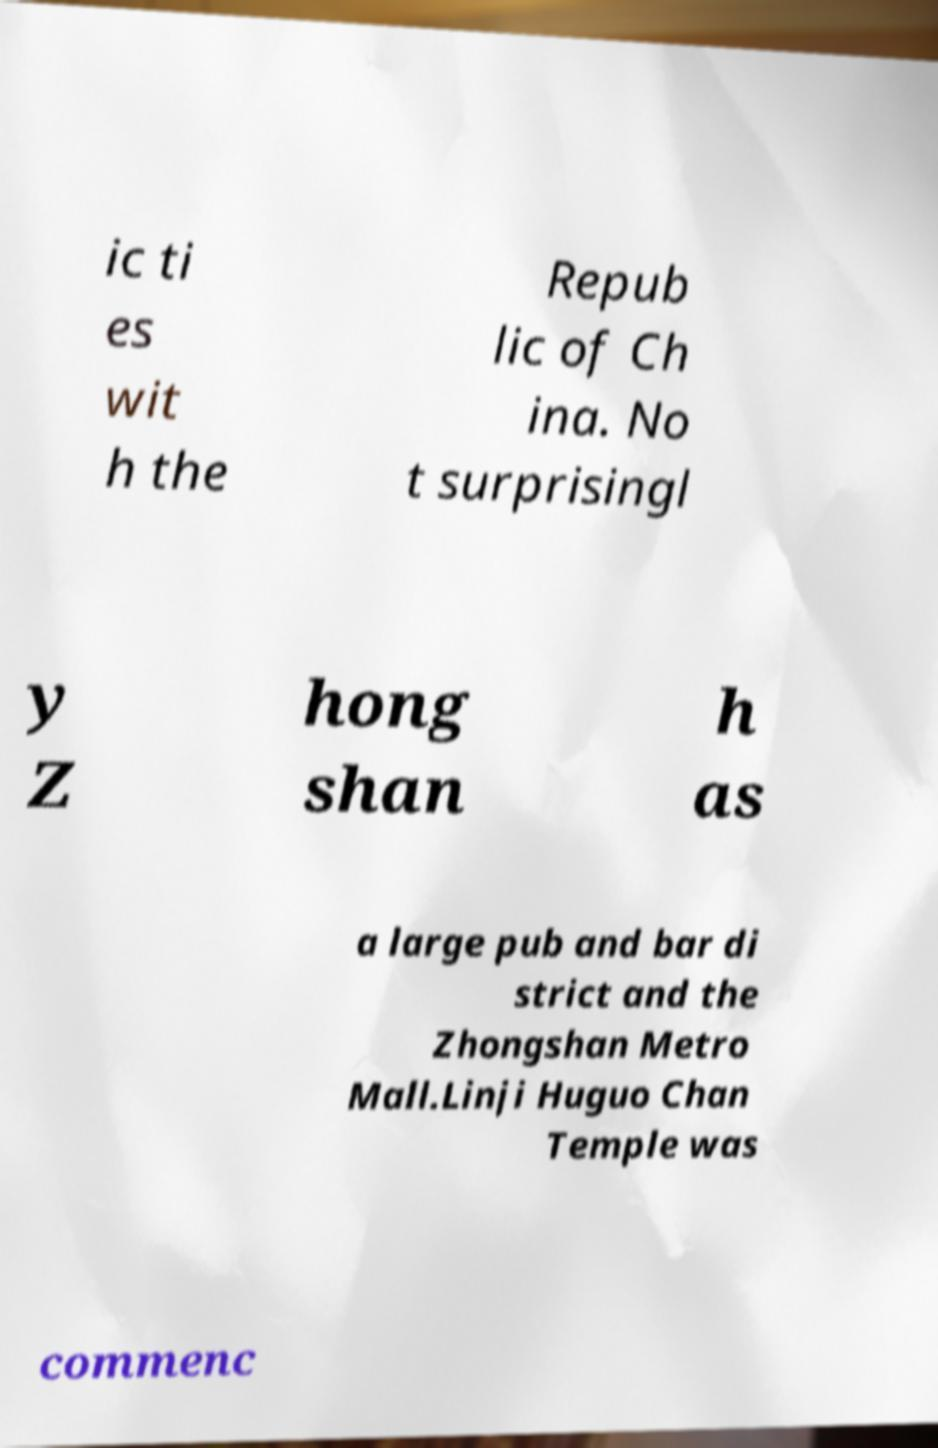Could you extract and type out the text from this image? ic ti es wit h the Repub lic of Ch ina. No t surprisingl y Z hong shan h as a large pub and bar di strict and the Zhongshan Metro Mall.Linji Huguo Chan Temple was commenc 